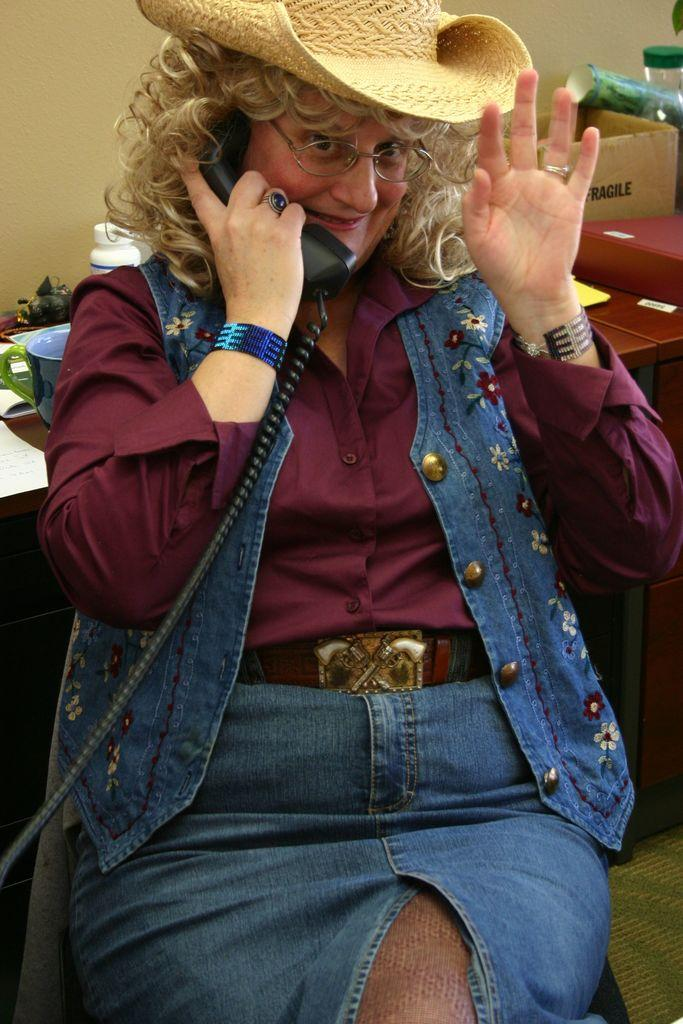Who is the main subject in the image? There is a woman in the image. What is the woman doing in the image? The woman is talking on the phone. Can you describe the woman's appearance? The woman has spectacles and is wearing a hat. What can be seen in the background of the image? There is a table, papers, a box, and a wall in the background of the image. What type of feather can be seen on the woman's hat in the image? There is no feather visible on the woman's hat in the image. Can you tell me how many worms are crawling on the table in the image? There are no worms present in the image; only a table, papers, and a box are visible on the table. 